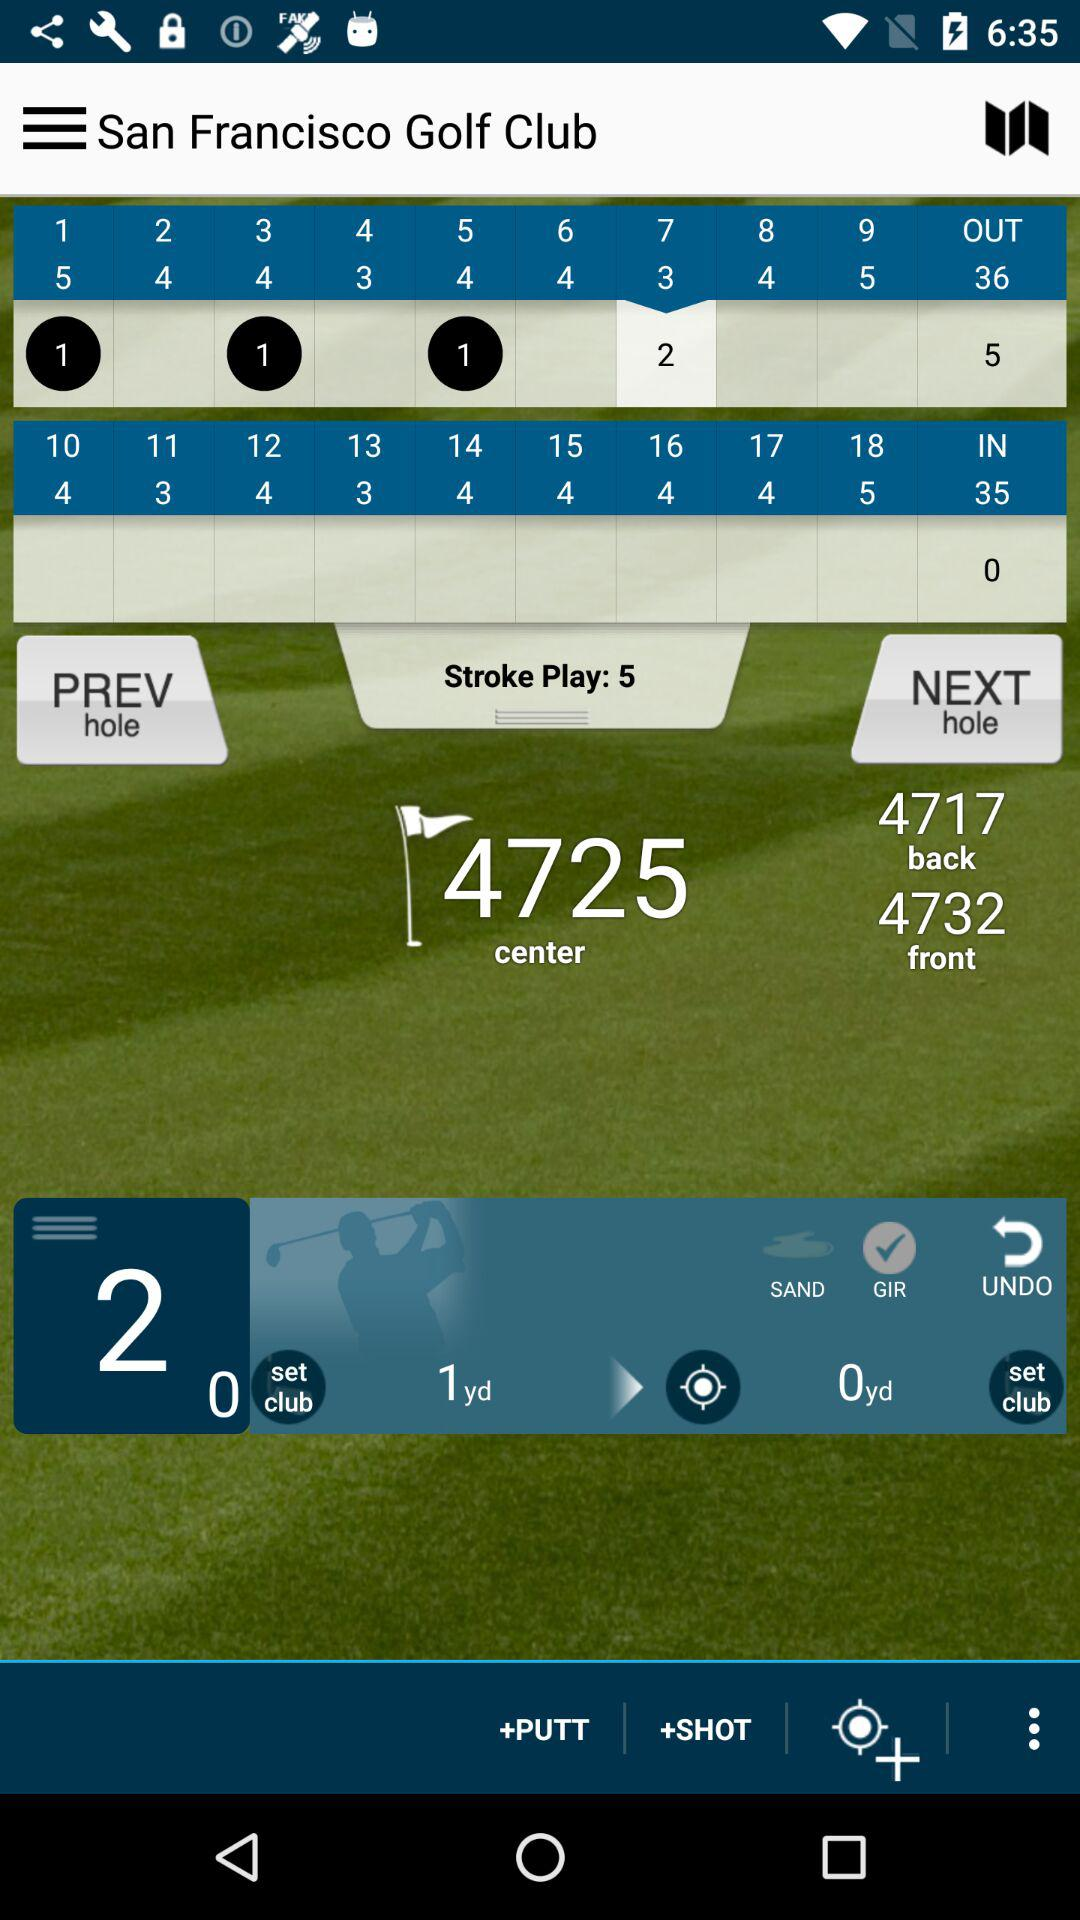What is the total number of "OUT"? The total number of "OUT" is 36. 